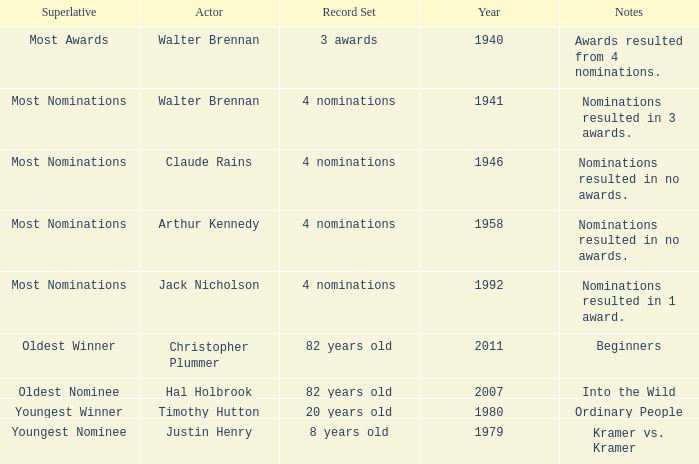When is the initial year that notes feature common people? 1980.0. 